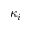<formula> <loc_0><loc_0><loc_500><loc_500>\kappa _ { i }</formula> 